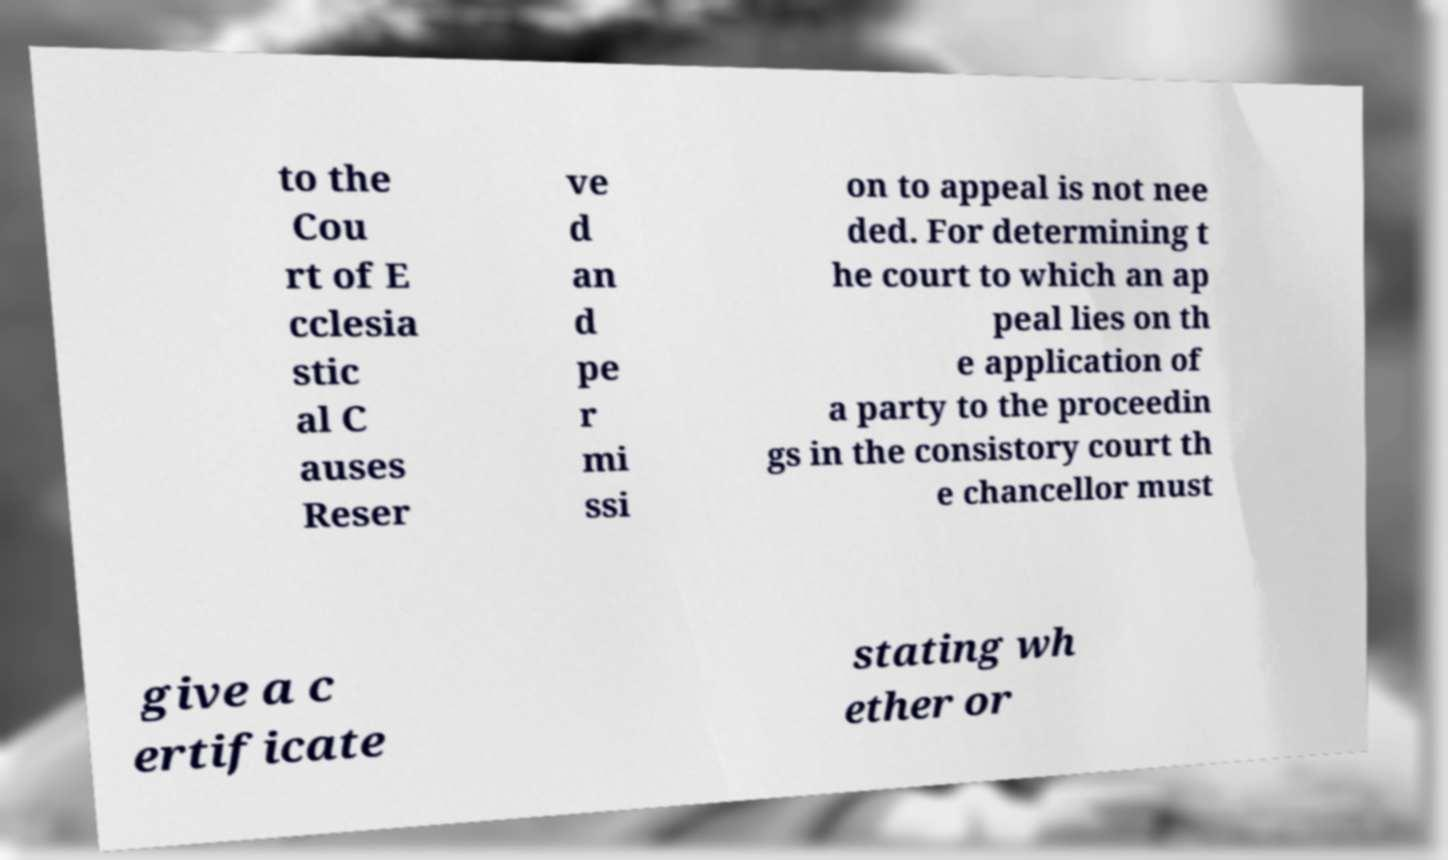Can you read and provide the text displayed in the image?This photo seems to have some interesting text. Can you extract and type it out for me? to the Cou rt of E cclesia stic al C auses Reser ve d an d pe r mi ssi on to appeal is not nee ded. For determining t he court to which an ap peal lies on th e application of a party to the proceedin gs in the consistory court th e chancellor must give a c ertificate stating wh ether or 